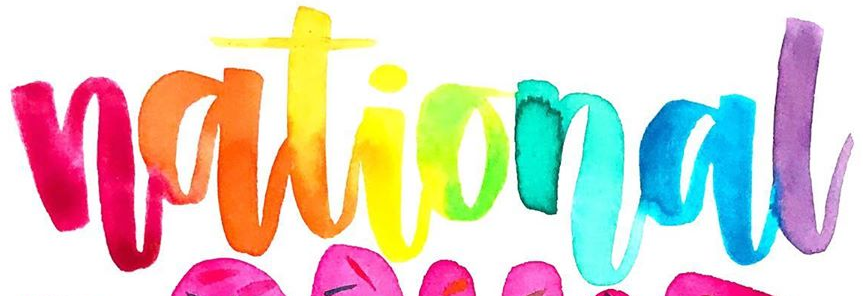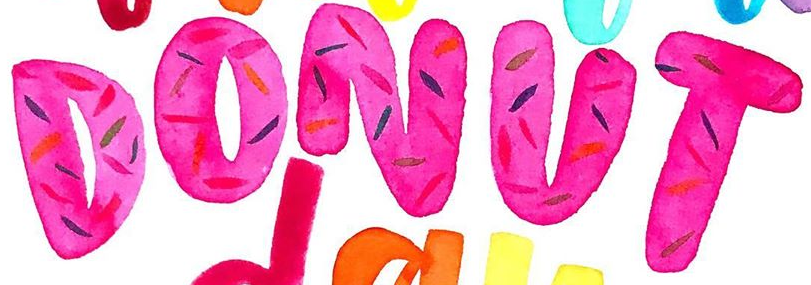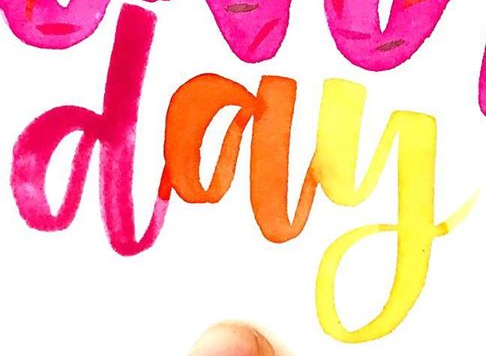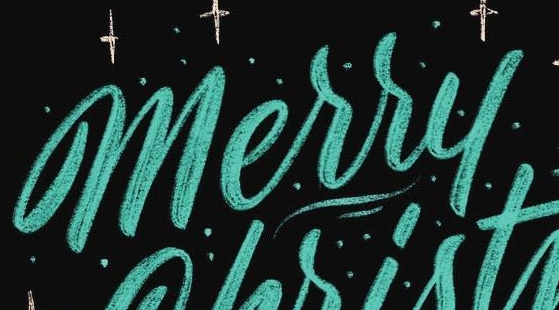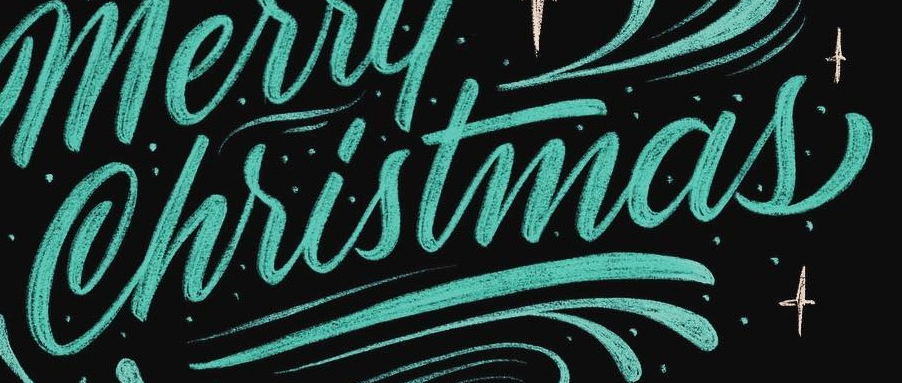What words are shown in these images in order, separated by a semicolon? national; DONUT; day; Merry; Christmas 